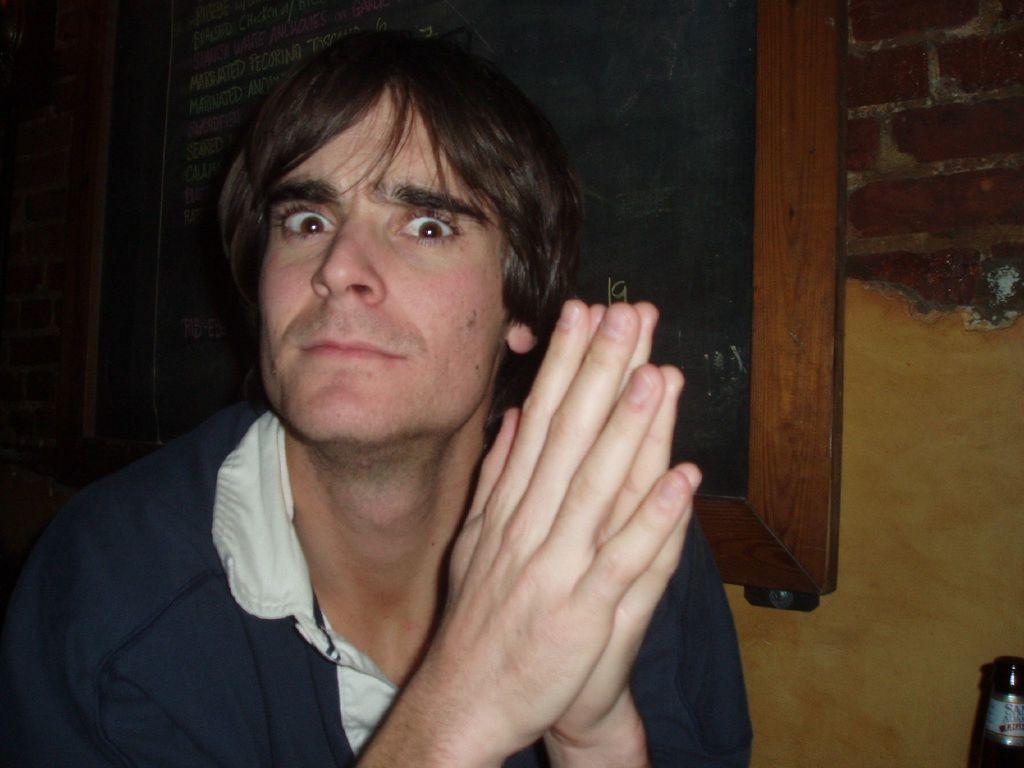Please provide a concise description of this image. In the foreground of this image, there is a man. In the background, there is a black board, wall and a bottle in the right bottom corner. 